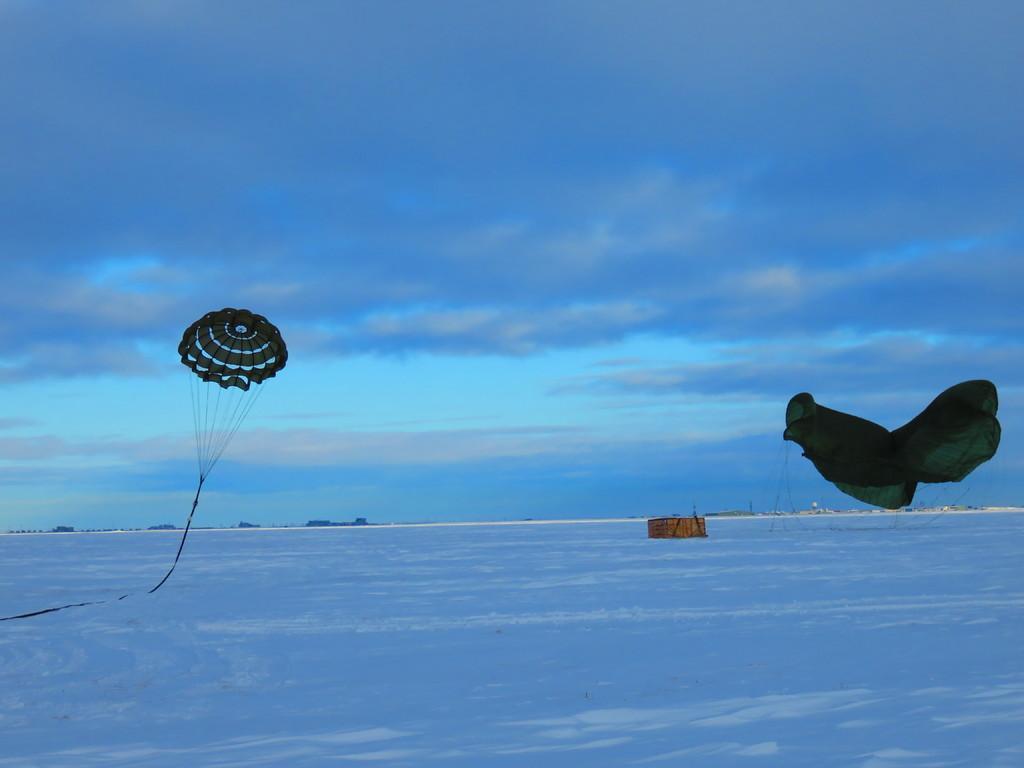In one or two sentences, can you explain what this image depicts? In this picture I can see snow. I can see clouds in the sky. I can see parachutes. 